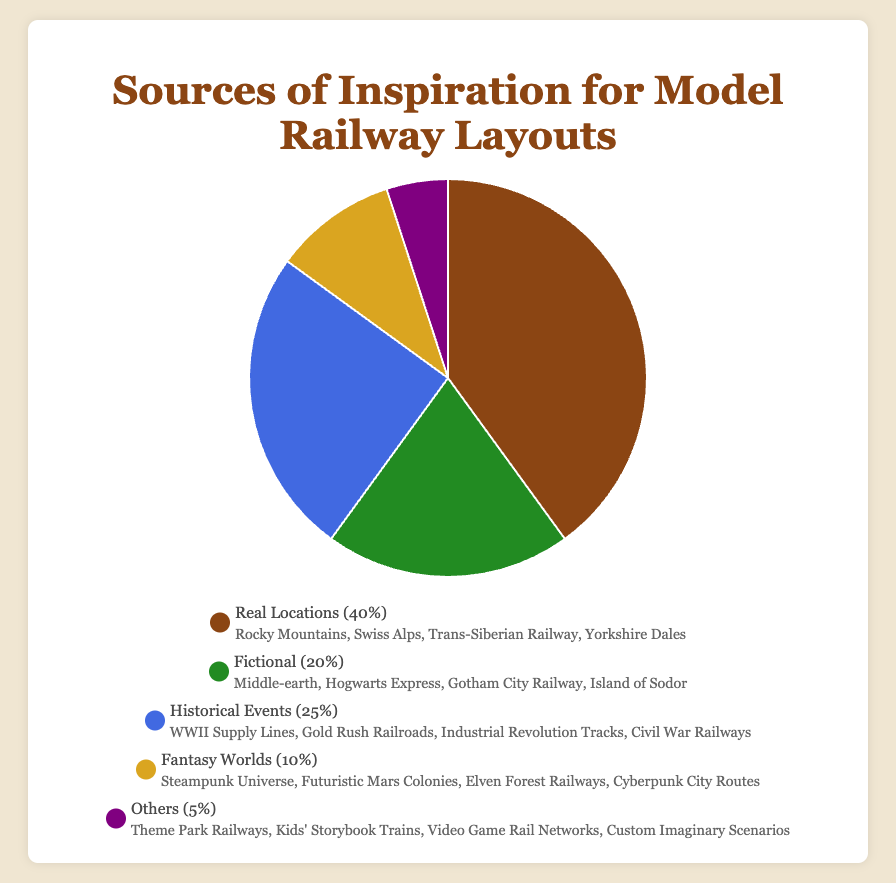What are the different sources of inspiration shown in the chart? The chart shows the following categories of sources of inspiration: Real Locations, Fictional, Historical Events, Fantasy Worlds, and Others.
Answer: Real Locations, Fictional, Historical Events, Fantasy Worlds, Others Which source of inspiration takes up the largest portion of the pie chart? By observing the pie chart, the largest segment corresponds to Real Locations, which makes up 40% of the chart.
Answer: Real Locations How many categories together make up less than 20% of the inspiration sources? By adding the percentages of Fantasy Worlds and Others, we obtain 10% + 5% = 15%, which is less than 20%.
Answer: Two What is the combined percentage of Historical Events and Fantasy Worlds as sources of inspiration? By summing up the percentages, Historical Events (25%) and Fantasy Worlds (10%) together make up 25% + 10% = 35%.
Answer: 35% Which categories are represented by green and yellow colors in the pie chart? By checking the colors associated with the respective categories: green represents Fictional and yellow represents Fantasy Worlds.
Answer: Fictional, Fantasy Worlds How does the percentage of Real Locations compare to that of Fictional inspirations? Real Locations account for 40%, whereas Fictional inspirations account for 20%. Therefore, Real Locations are twice as common as Fictional inspirations.
Answer: Twice as common What is the percentage difference between Historical Events and Others as sources of inspiration? The percentage for Historical Events is 25% and for Others is 5%. The difference is 25% - 5% = 20%.
Answer: 20% What sources of inspiration are visually represented in the pie chart with similar proportions? Fictional at 20% and Historical Events at 25% are the most similar in size, visually represented in the pie chart.
Answer: Fictional, Historical Events Among the listed sources, which ones contribute the least to the inspiration for model railway layouts? Observing the pie chart, the category Others contributes the least with 5%.
Answer: Others 